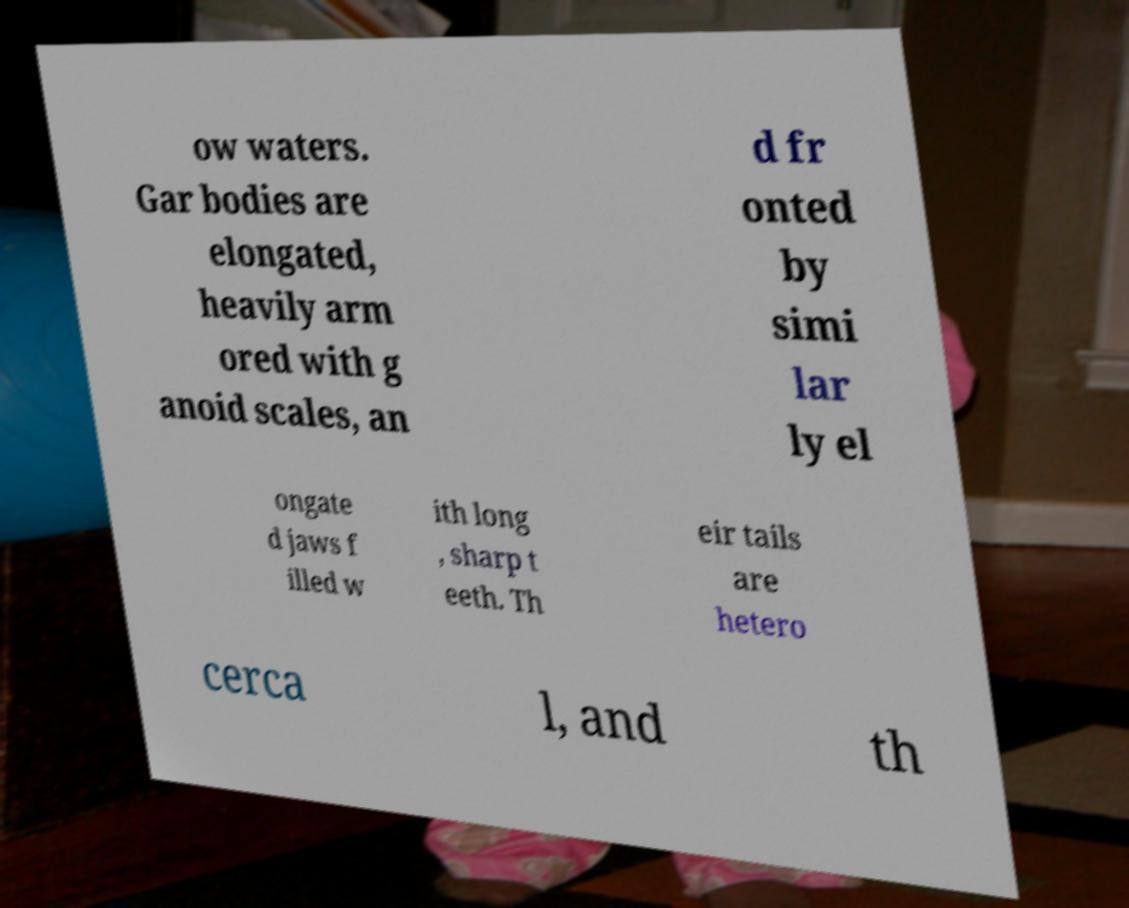Can you accurately transcribe the text from the provided image for me? ow waters. Gar bodies are elongated, heavily arm ored with g anoid scales, an d fr onted by simi lar ly el ongate d jaws f illed w ith long , sharp t eeth. Th eir tails are hetero cerca l, and th 